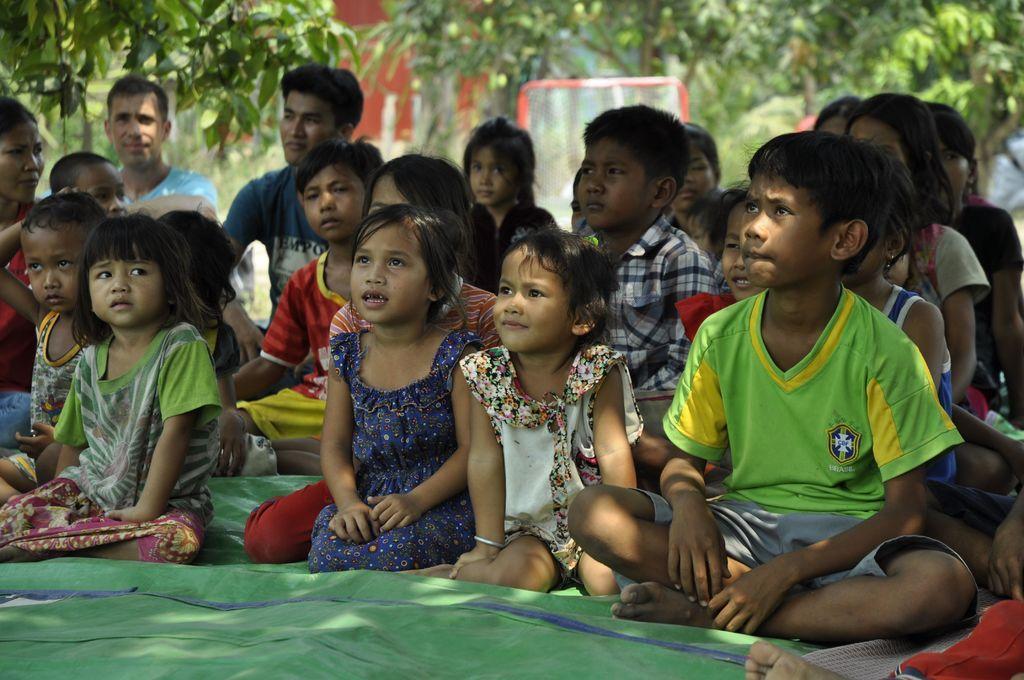Can you describe this image briefly? In the image there are few kids and men sitting on the green cloth. Behind them in the background there are trees and also there is a net. 